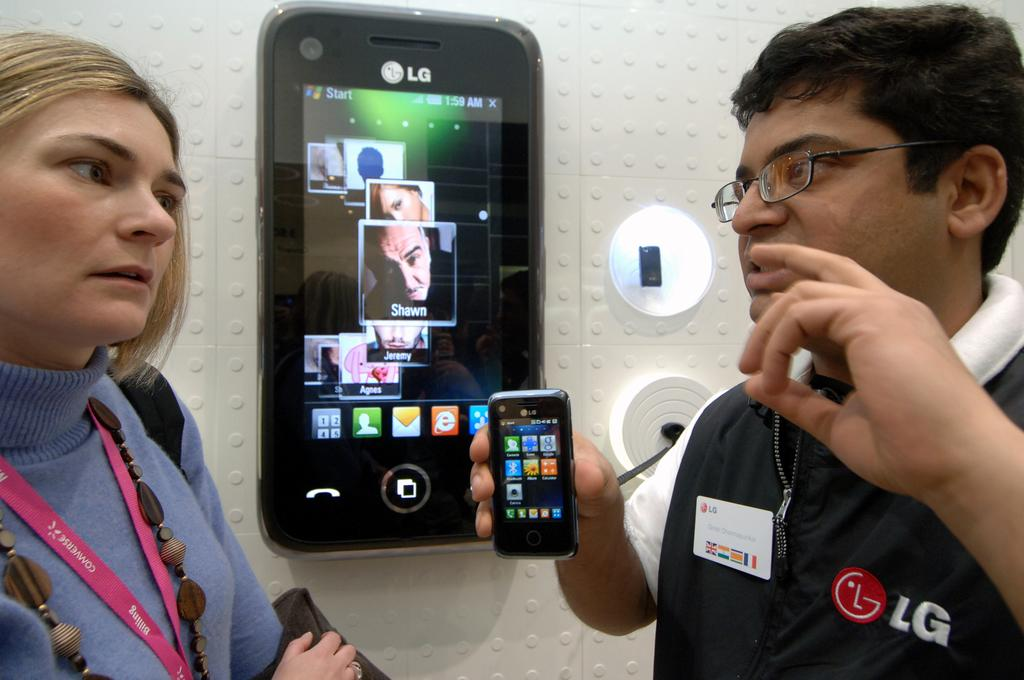What is the person in the image doing? The person is riding a bicycle on a road. What mode of transportation is the person using? The person is using a bicycle. Where is the person located in the image? The person is on a road. What type of beam can be seen in the image? There is no beam present in the image; it features a person riding a bicycle on a road. What sound can be heard in the image? The image is silent, so no sound can be heard. 